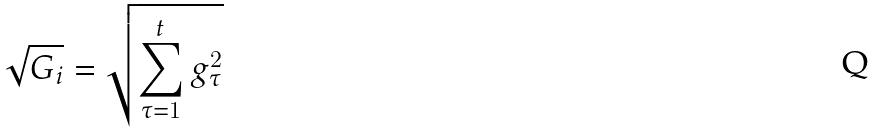<formula> <loc_0><loc_0><loc_500><loc_500>\sqrt { G _ { i } } = \sqrt { \sum _ { \tau = 1 } ^ { t } g _ { \tau } ^ { 2 } }</formula> 